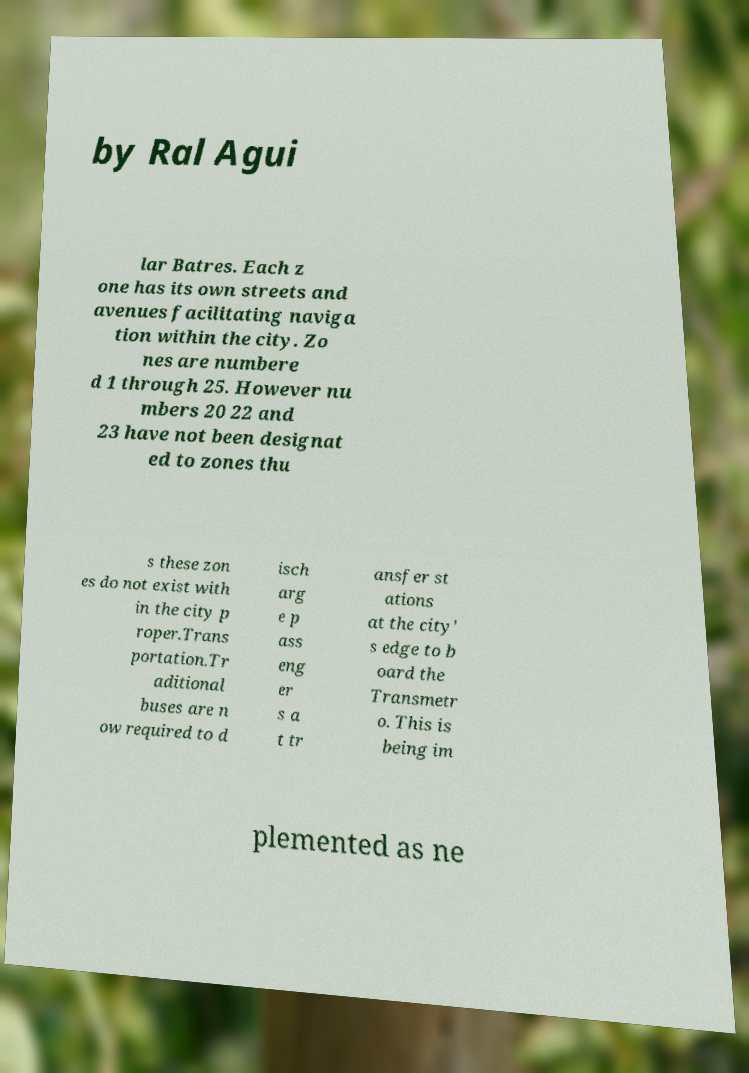I need the written content from this picture converted into text. Can you do that? by Ral Agui lar Batres. Each z one has its own streets and avenues facilitating naviga tion within the city. Zo nes are numbere d 1 through 25. However nu mbers 20 22 and 23 have not been designat ed to zones thu s these zon es do not exist with in the city p roper.Trans portation.Tr aditional buses are n ow required to d isch arg e p ass eng er s a t tr ansfer st ations at the city' s edge to b oard the Transmetr o. This is being im plemented as ne 